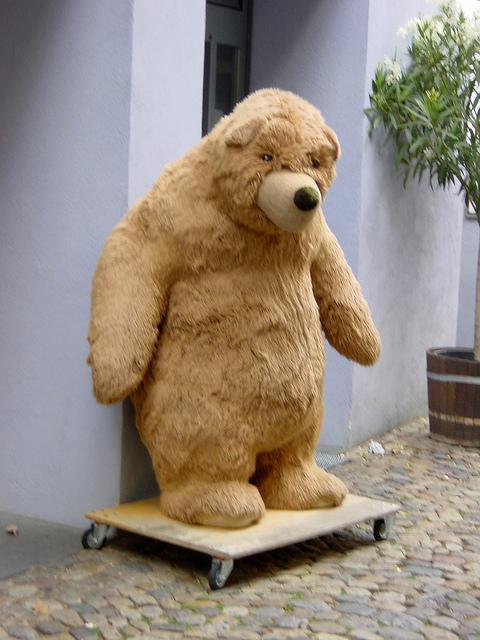Is the caption "The potted plant is in front of the teddy bear." a true representation of the image?
Answer yes or no. No. Is "The teddy bear is at the left side of the potted plant." an appropriate description for the image?
Answer yes or no. Yes. 